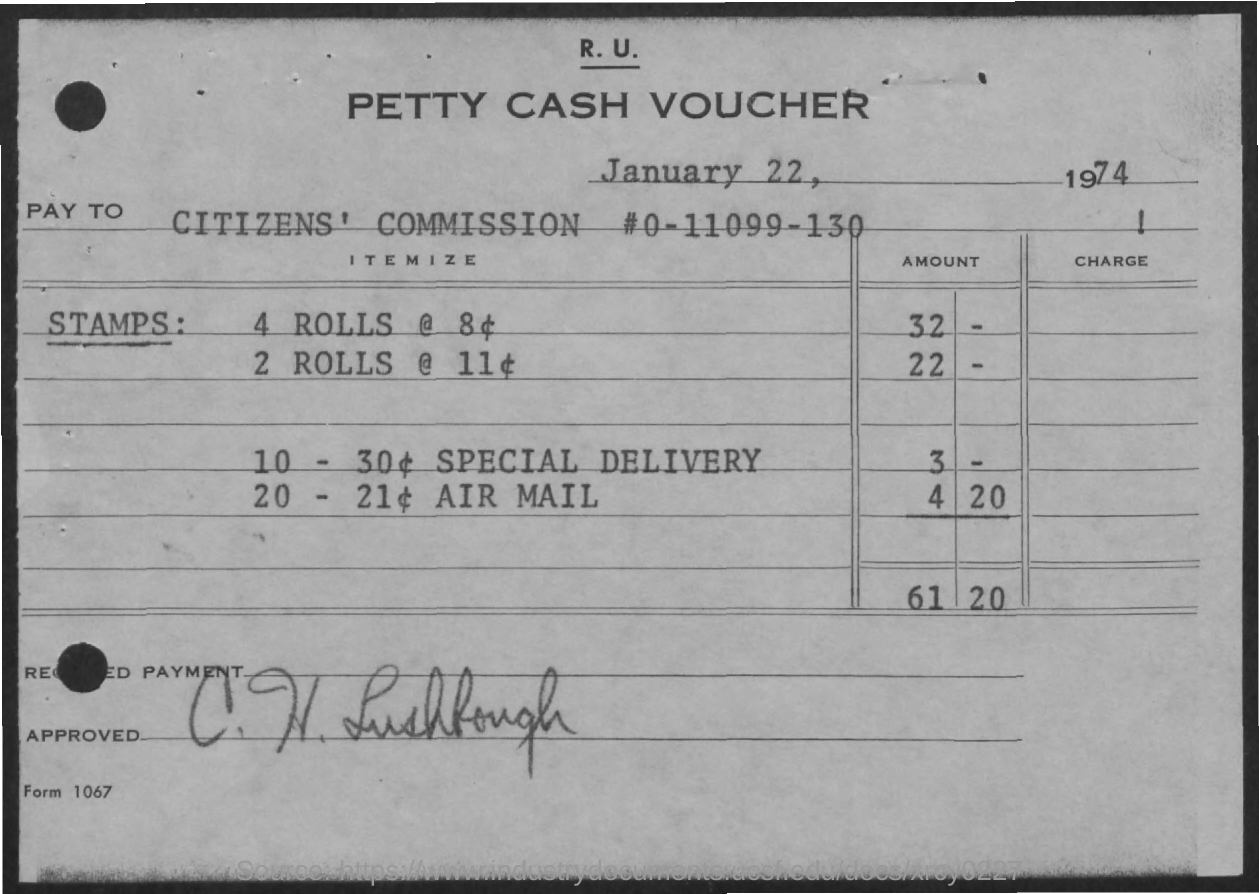What is voucher for?
Ensure brevity in your answer.  Petty Cash Voucher. What is the total amount for stamps?
Keep it short and to the point. 61-20. What is the date of cash voucher issued?
Provide a short and direct response. January 22, 1974. What is the cost of 4 Rolls?
Ensure brevity in your answer.  32. What is the amount in cash voucher for special delivery?
Your answer should be very brief. 3 -. 